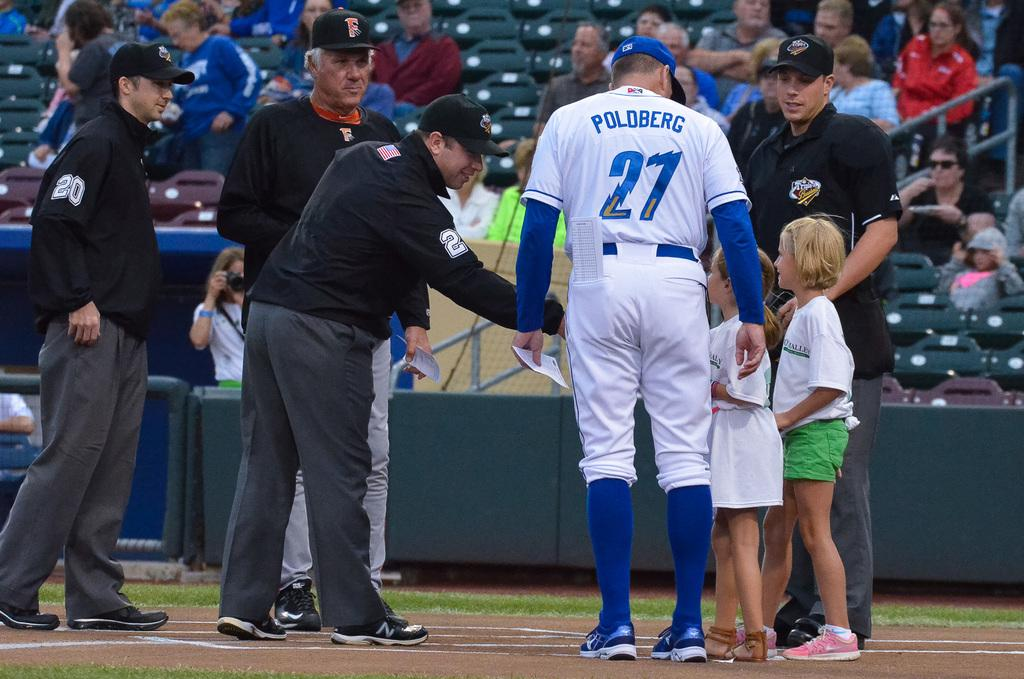<image>
Present a compact description of the photo's key features. A baseball player standing with two kids with the name Poldberg on the back of his jersey. 